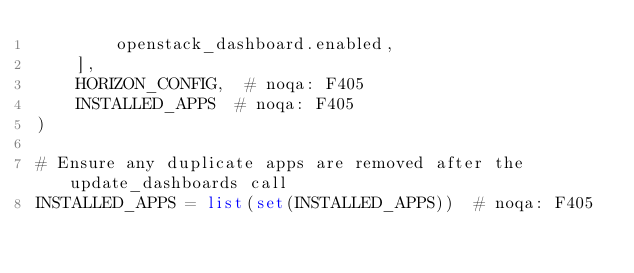Convert code to text. <code><loc_0><loc_0><loc_500><loc_500><_Python_>        openstack_dashboard.enabled,
    ],
    HORIZON_CONFIG,  # noqa: F405
    INSTALLED_APPS  # noqa: F405
)

# Ensure any duplicate apps are removed after the update_dashboards call
INSTALLED_APPS = list(set(INSTALLED_APPS))  # noqa: F405
</code> 